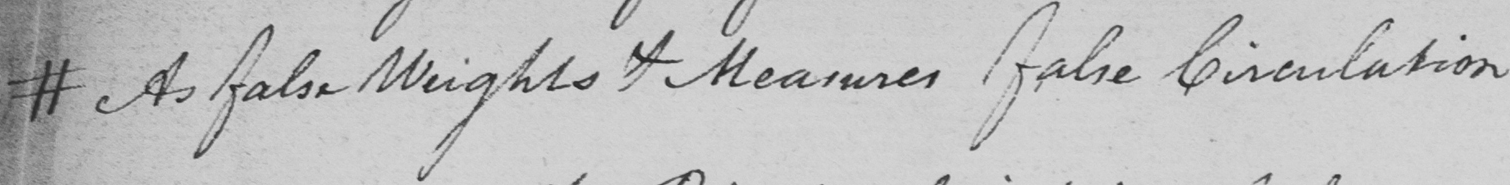Can you tell me what this handwritten text says? # As false Weights & Measures false Circulation 